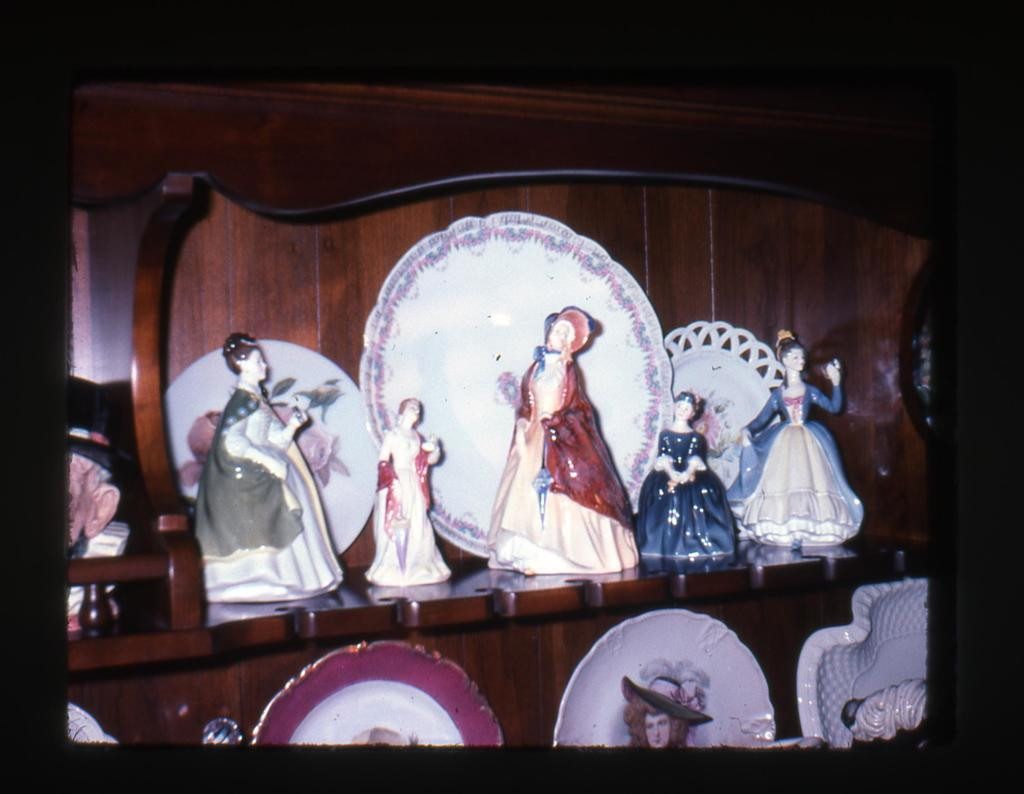What objects can be seen on the shelves in the image? There are plates and statues arranged on shelves in the image. What is the color of the background in the image? The background of the image is dark in color. Can you see any clover growing in the image? There is no clover present in the image. What type of scene is depicted in the image? The image does not depict a scene; it shows objects arranged on shelves. 